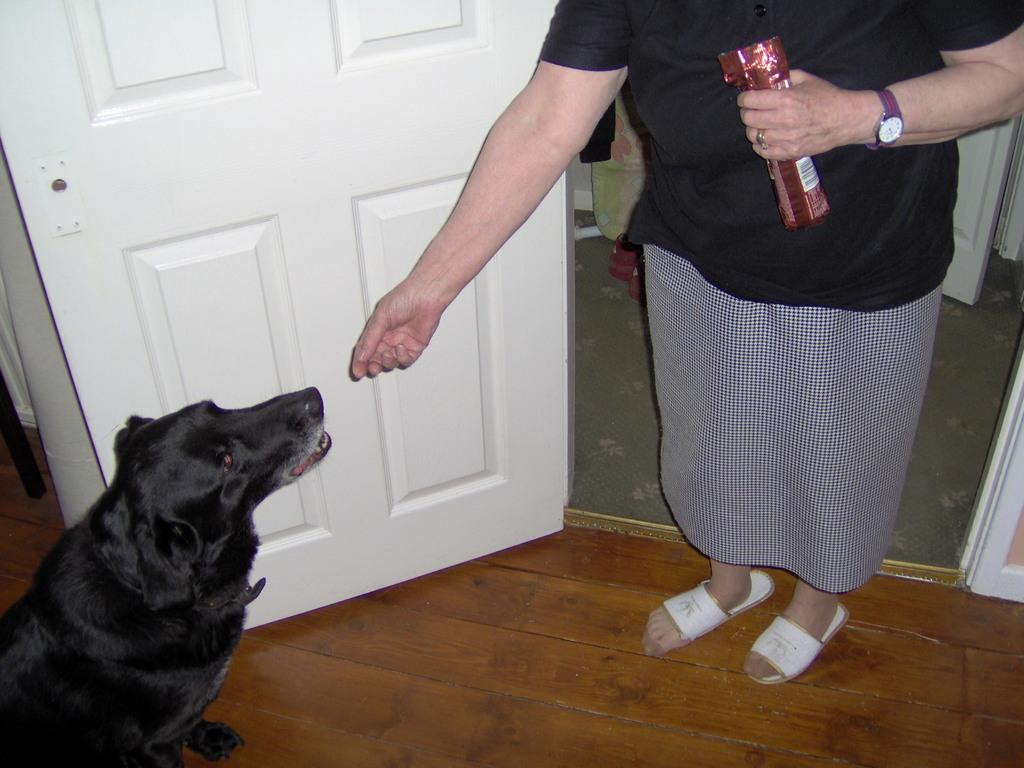What animal is on the left side of the image? There is a dog on the left side of the image. Who is on the right side of the image? There is a lady on the right side of the image. What is the lady doing in the image? The lady is standing in the image. What is the lady holding in her hand? The lady is holding a biscuit packet in her hand. What time is displayed on the clock in the image? There is no clock present in the image. Is the dog's dad visible in the image? There is no reference to a dog's dad in the image, so it cannot be determined if he is present. 